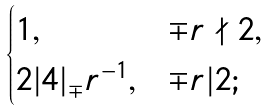<formula> <loc_0><loc_0><loc_500><loc_500>\begin{cases} 1 , & \mp r \nmid 2 , \\ 2 { | 4 | } _ { \mp } r ^ { - 1 } , & \mp r | 2 ; \end{cases}</formula> 